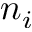<formula> <loc_0><loc_0><loc_500><loc_500>n _ { i }</formula> 